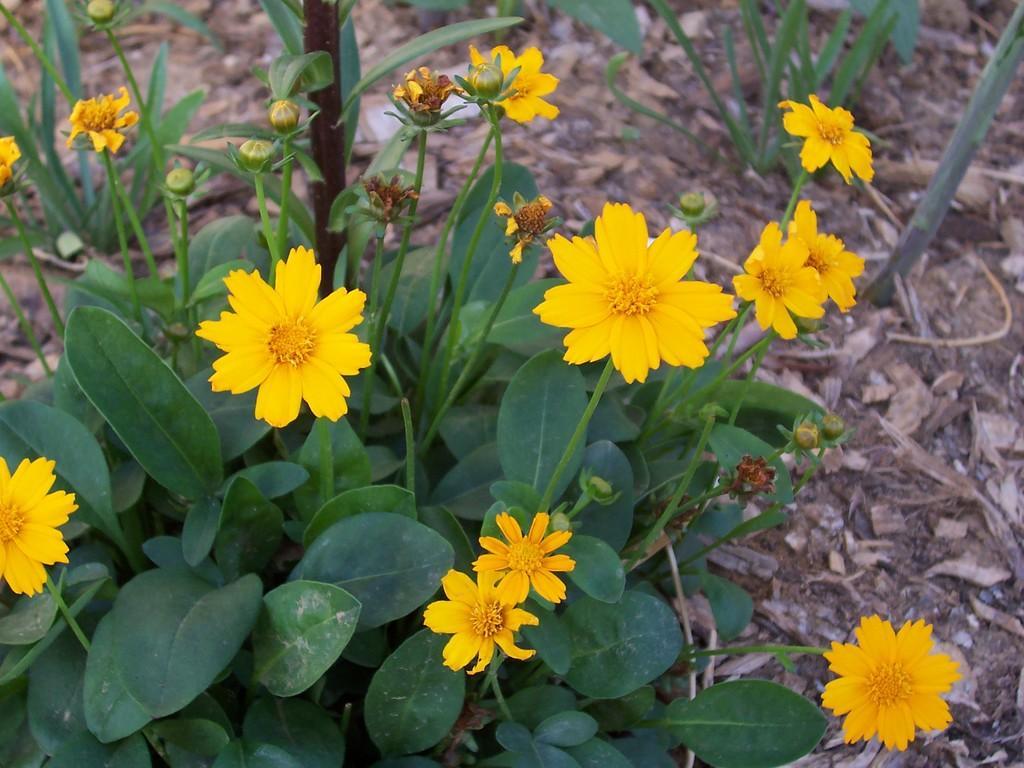Could you give a brief overview of what you see in this image? In this image we can see yellow color flowers plants with leaves and stem and on land dry leaves are there. 